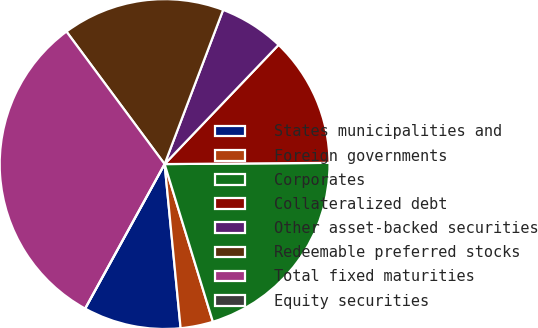Convert chart. <chart><loc_0><loc_0><loc_500><loc_500><pie_chart><fcel>States municipalities and<fcel>Foreign governments<fcel>Corporates<fcel>Collateralized debt<fcel>Other asset-backed securities<fcel>Redeemable preferred stocks<fcel>Total fixed maturities<fcel>Equity securities<nl><fcel>9.55%<fcel>3.18%<fcel>20.39%<fcel>12.74%<fcel>6.37%<fcel>15.92%<fcel>31.85%<fcel>0.0%<nl></chart> 